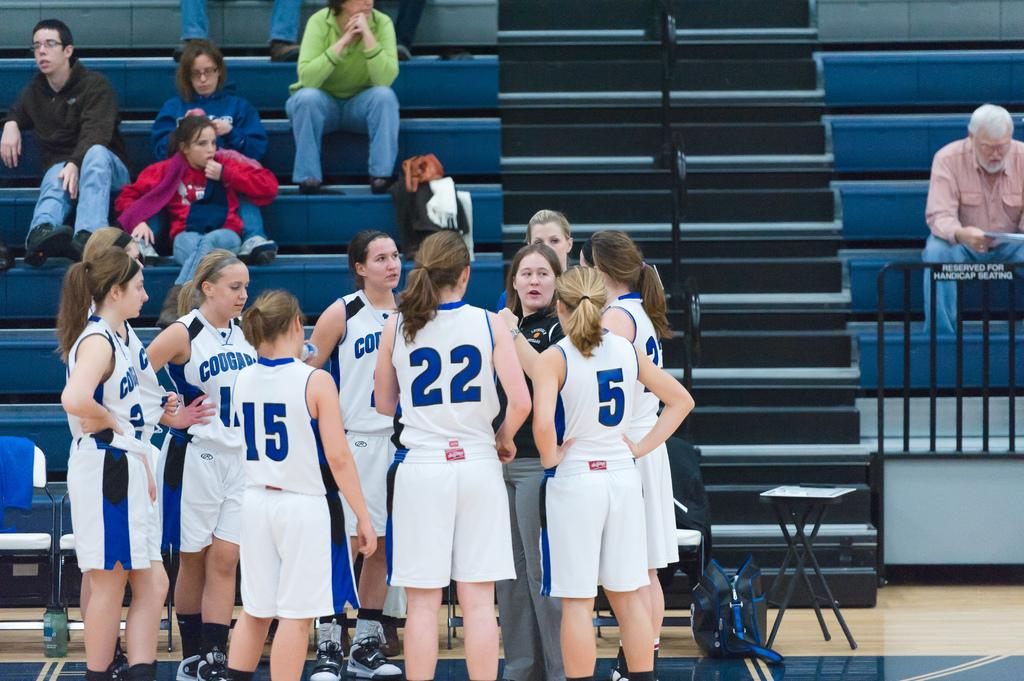Provide a one-sentence caption for the provided image. The Cougars female basketball team huddles in front of the bleachers. 